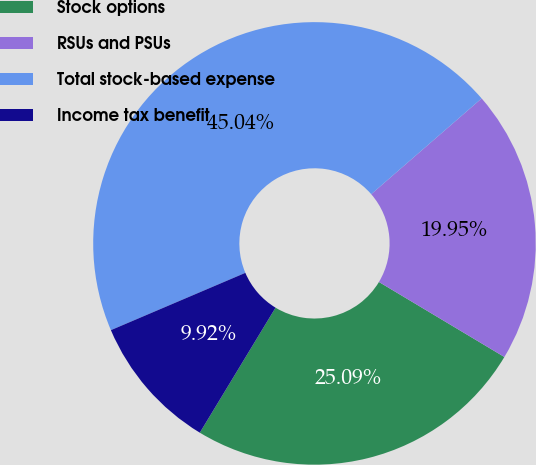Convert chart to OTSL. <chart><loc_0><loc_0><loc_500><loc_500><pie_chart><fcel>Stock options<fcel>RSUs and PSUs<fcel>Total stock-based expense<fcel>Income tax benefit<nl><fcel>25.09%<fcel>19.95%<fcel>45.04%<fcel>9.92%<nl></chart> 